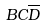Convert formula to latex. <formula><loc_0><loc_0><loc_500><loc_500>B C \overline { D }</formula> 